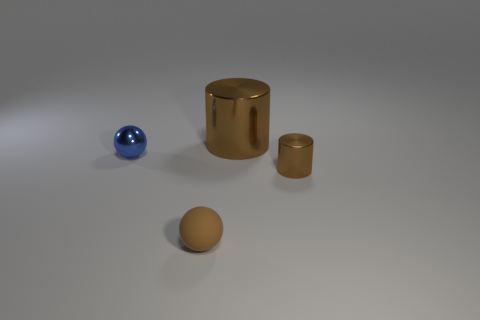How many other objects are the same material as the small blue thing?
Your answer should be very brief. 2. How many objects are either metallic cylinders on the right side of the big metallic cylinder or big brown shiny things?
Your response must be concise. 2. What is the shape of the small object behind the small brown thing behind the small brown matte sphere?
Keep it short and to the point. Sphere. Do the brown metal object that is in front of the blue object and the small blue thing have the same shape?
Keep it short and to the point. No. What is the color of the small ball behind the rubber thing?
Offer a terse response. Blue. What number of spheres are matte objects or tiny blue shiny objects?
Offer a terse response. 2. What is the size of the brown object that is behind the brown shiny cylinder in front of the big metallic object?
Your answer should be compact. Large. There is a small matte object; does it have the same color as the small metallic object that is on the left side of the large shiny cylinder?
Your response must be concise. No. There is a big cylinder; how many metallic cylinders are on the right side of it?
Make the answer very short. 1. Are there fewer small blue shiny objects than large red blocks?
Your answer should be very brief. No. 